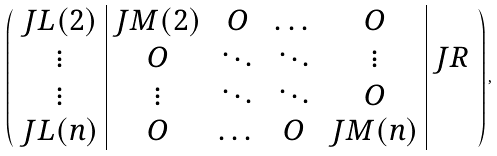<formula> <loc_0><loc_0><loc_500><loc_500>\begin{pmatrix} \begin{array} { c | c c c c | c } J L ( 2 ) & J M ( 2 ) & O & \dots & O & \\ \vdots & O & \ddots & \ddots & \vdots & J R \\ \vdots & \vdots & \ddots & \ddots & O & \\ J L ( n ) & O & \dots & O & J M ( n ) & \\ \end{array} \end{pmatrix} ,</formula> 